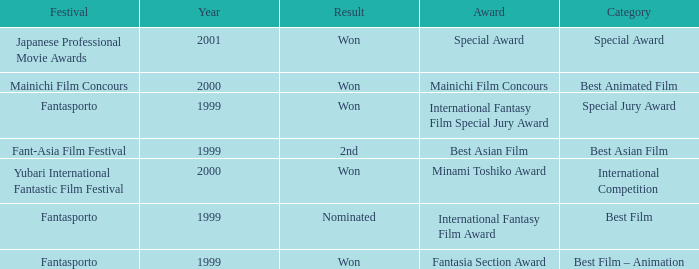What is the average year of the Fantasia Section Award? 1999.0. 